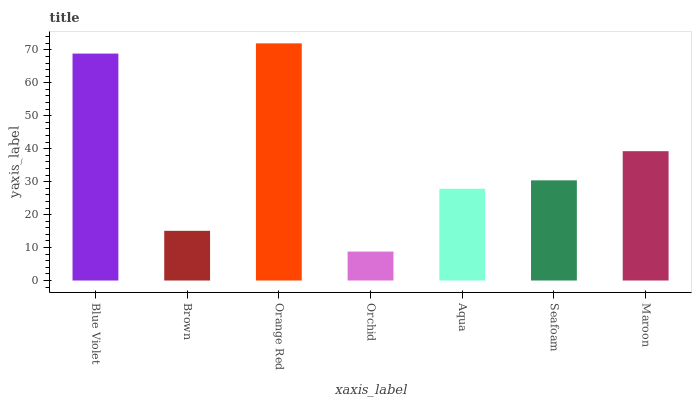Is Brown the minimum?
Answer yes or no. No. Is Brown the maximum?
Answer yes or no. No. Is Blue Violet greater than Brown?
Answer yes or no. Yes. Is Brown less than Blue Violet?
Answer yes or no. Yes. Is Brown greater than Blue Violet?
Answer yes or no. No. Is Blue Violet less than Brown?
Answer yes or no. No. Is Seafoam the high median?
Answer yes or no. Yes. Is Seafoam the low median?
Answer yes or no. Yes. Is Blue Violet the high median?
Answer yes or no. No. Is Brown the low median?
Answer yes or no. No. 